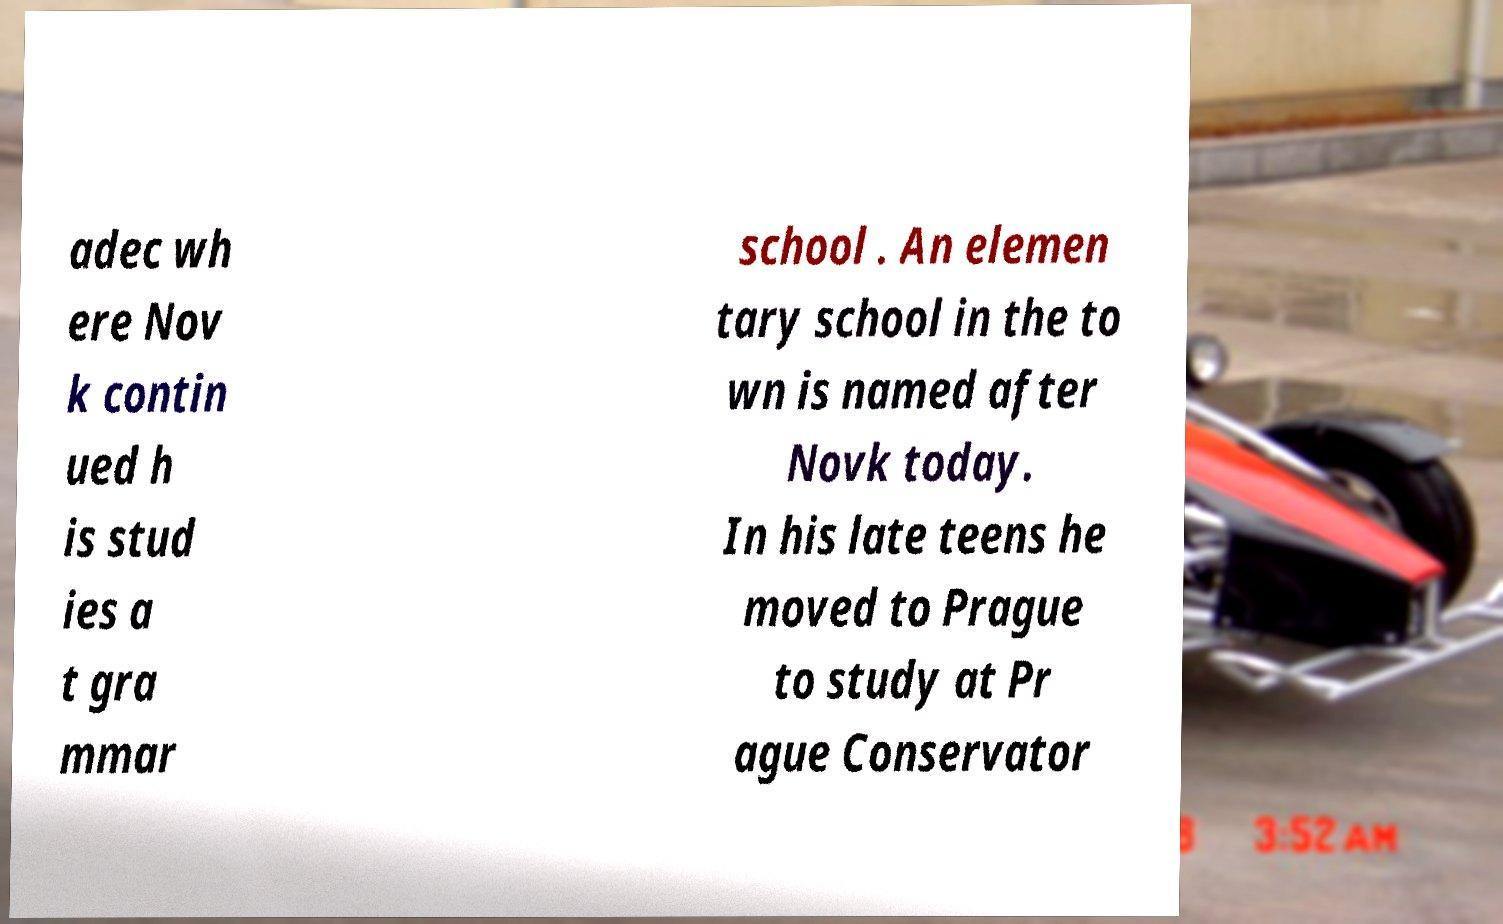Can you accurately transcribe the text from the provided image for me? adec wh ere Nov k contin ued h is stud ies a t gra mmar school . An elemen tary school in the to wn is named after Novk today. In his late teens he moved to Prague to study at Pr ague Conservator 